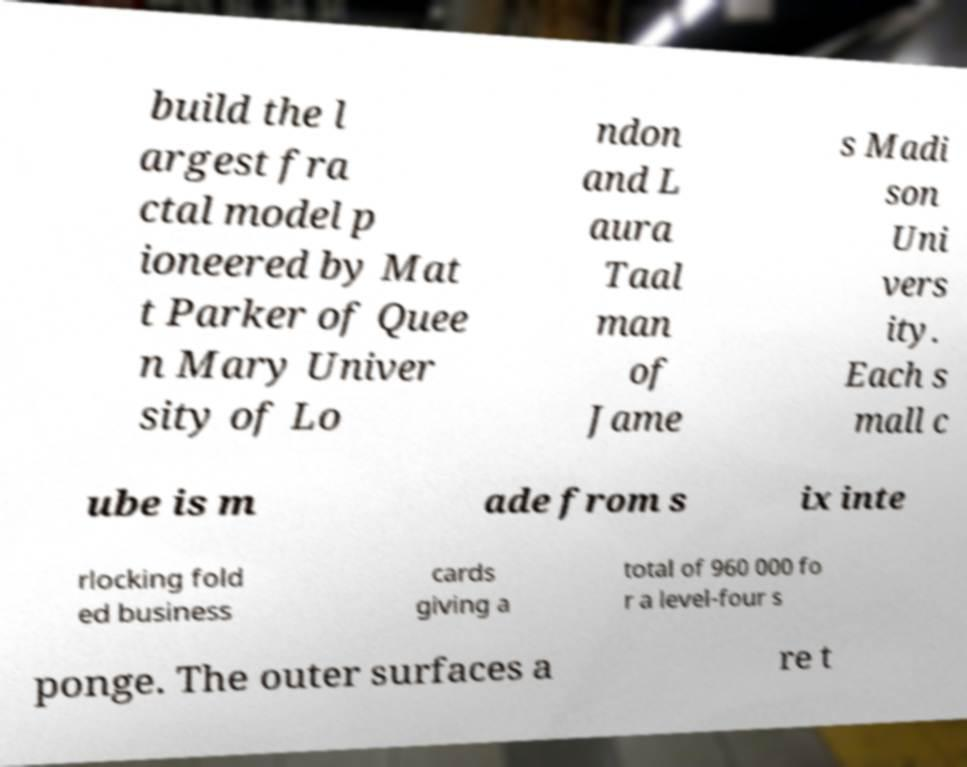Can you read and provide the text displayed in the image?This photo seems to have some interesting text. Can you extract and type it out for me? build the l argest fra ctal model p ioneered by Mat t Parker of Quee n Mary Univer sity of Lo ndon and L aura Taal man of Jame s Madi son Uni vers ity. Each s mall c ube is m ade from s ix inte rlocking fold ed business cards giving a total of 960 000 fo r a level-four s ponge. The outer surfaces a re t 